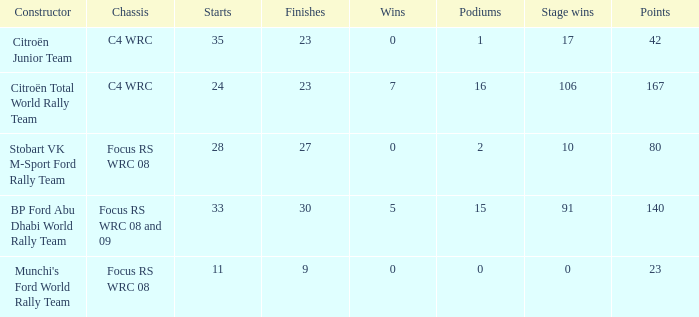What is the total number of points when the constructor is citroën total world rally team and the wins is less than 7? 0.0. 